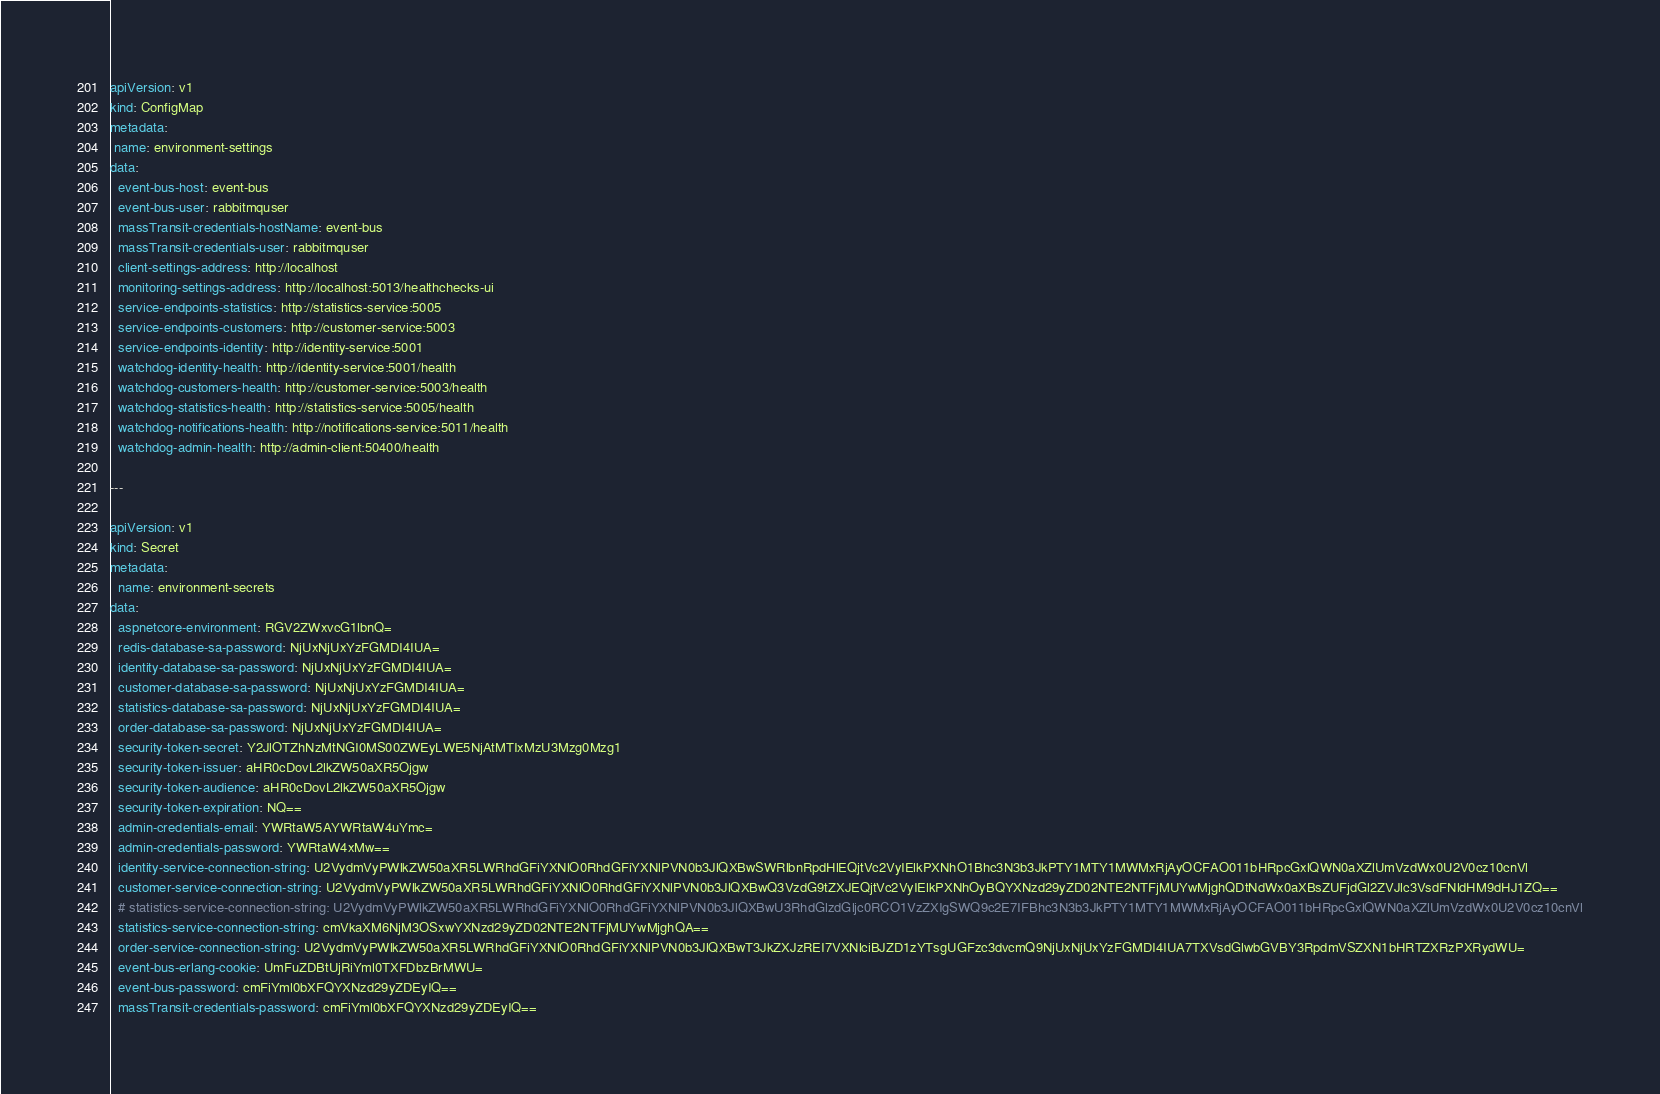<code> <loc_0><loc_0><loc_500><loc_500><_YAML_>apiVersion: v1
kind: ConfigMap
metadata:
 name: environment-settings
data:
  event-bus-host: event-bus
  event-bus-user: rabbitmquser
  massTransit-credentials-hostName: event-bus
  massTransit-credentials-user: rabbitmquser
  client-settings-address: http://localhost
  monitoring-settings-address: http://localhost:5013/healthchecks-ui
  service-endpoints-statistics: http://statistics-service:5005
  service-endpoints-customers: http://customer-service:5003
  service-endpoints-identity: http://identity-service:5001
  watchdog-identity-health: http://identity-service:5001/health
  watchdog-customers-health: http://customer-service:5003/health
  watchdog-statistics-health: http://statistics-service:5005/health
  watchdog-notifications-health: http://notifications-service:5011/health
  watchdog-admin-health: http://admin-client:50400/health

---

apiVersion: v1
kind: Secret
metadata:
  name: environment-secrets
data:
  aspnetcore-environment: RGV2ZWxvcG1lbnQ=
  redis-database-sa-password: NjUxNjUxYzFGMDI4IUA=
  identity-database-sa-password: NjUxNjUxYzFGMDI4IUA=
  customer-database-sa-password: NjUxNjUxYzFGMDI4IUA=
  statistics-database-sa-password: NjUxNjUxYzFGMDI4IUA=
  order-database-sa-password: NjUxNjUxYzFGMDI4IUA=
  security-token-secret: Y2JlOTZhNzMtNGI0MS00ZWEyLWE5NjAtMTIxMzU3Mzg0Mzg1
  security-token-issuer: aHR0cDovL2lkZW50aXR5Ojgw
  security-token-audience: aHR0cDovL2lkZW50aXR5Ojgw
  security-token-expiration: NQ==
  admin-credentials-email: YWRtaW5AYWRtaW4uYmc=
  admin-credentials-password: YWRtaW4xMw==
  identity-service-connection-string: U2VydmVyPWlkZW50aXR5LWRhdGFiYXNlO0RhdGFiYXNlPVN0b3JlQXBwSWRlbnRpdHlEQjtVc2VyIElkPXNhO1Bhc3N3b3JkPTY1MTY1MWMxRjAyOCFAO011bHRpcGxlQWN0aXZlUmVzdWx0U2V0cz10cnVl
  customer-service-connection-string: U2VydmVyPWlkZW50aXR5LWRhdGFiYXNlO0RhdGFiYXNlPVN0b3JlQXBwQ3VzdG9tZXJEQjtVc2VyIElkPXNhOyBQYXNzd29yZD02NTE2NTFjMUYwMjghQDtNdWx0aXBsZUFjdGl2ZVJlc3VsdFNldHM9dHJ1ZQ==
  # statistics-service-connection-string: U2VydmVyPWlkZW50aXR5LWRhdGFiYXNlO0RhdGFiYXNlPVN0b3JlQXBwU3RhdGlzdGljc0RCO1VzZXIgSWQ9c2E7IFBhc3N3b3JkPTY1MTY1MWMxRjAyOCFAO011bHRpcGxlQWN0aXZlUmVzdWx0U2V0cz10cnVl
  statistics-service-connection-string: cmVkaXM6NjM3OSxwYXNzd29yZD02NTE2NTFjMUYwMjghQA==
  order-service-connection-string: U2VydmVyPWlkZW50aXR5LWRhdGFiYXNlO0RhdGFiYXNlPVN0b3JlQXBwT3JkZXJzREI7VXNlciBJZD1zYTsgUGFzc3dvcmQ9NjUxNjUxYzFGMDI4IUA7TXVsdGlwbGVBY3RpdmVSZXN1bHRTZXRzPXRydWU=
  event-bus-erlang-cookie: UmFuZDBtUjRiYml0TXFDbzBrMWU=
  event-bus-password: cmFiYml0bXFQYXNzd29yZDEyIQ==
  massTransit-credentials-password: cmFiYml0bXFQYXNzd29yZDEyIQ==
</code> 